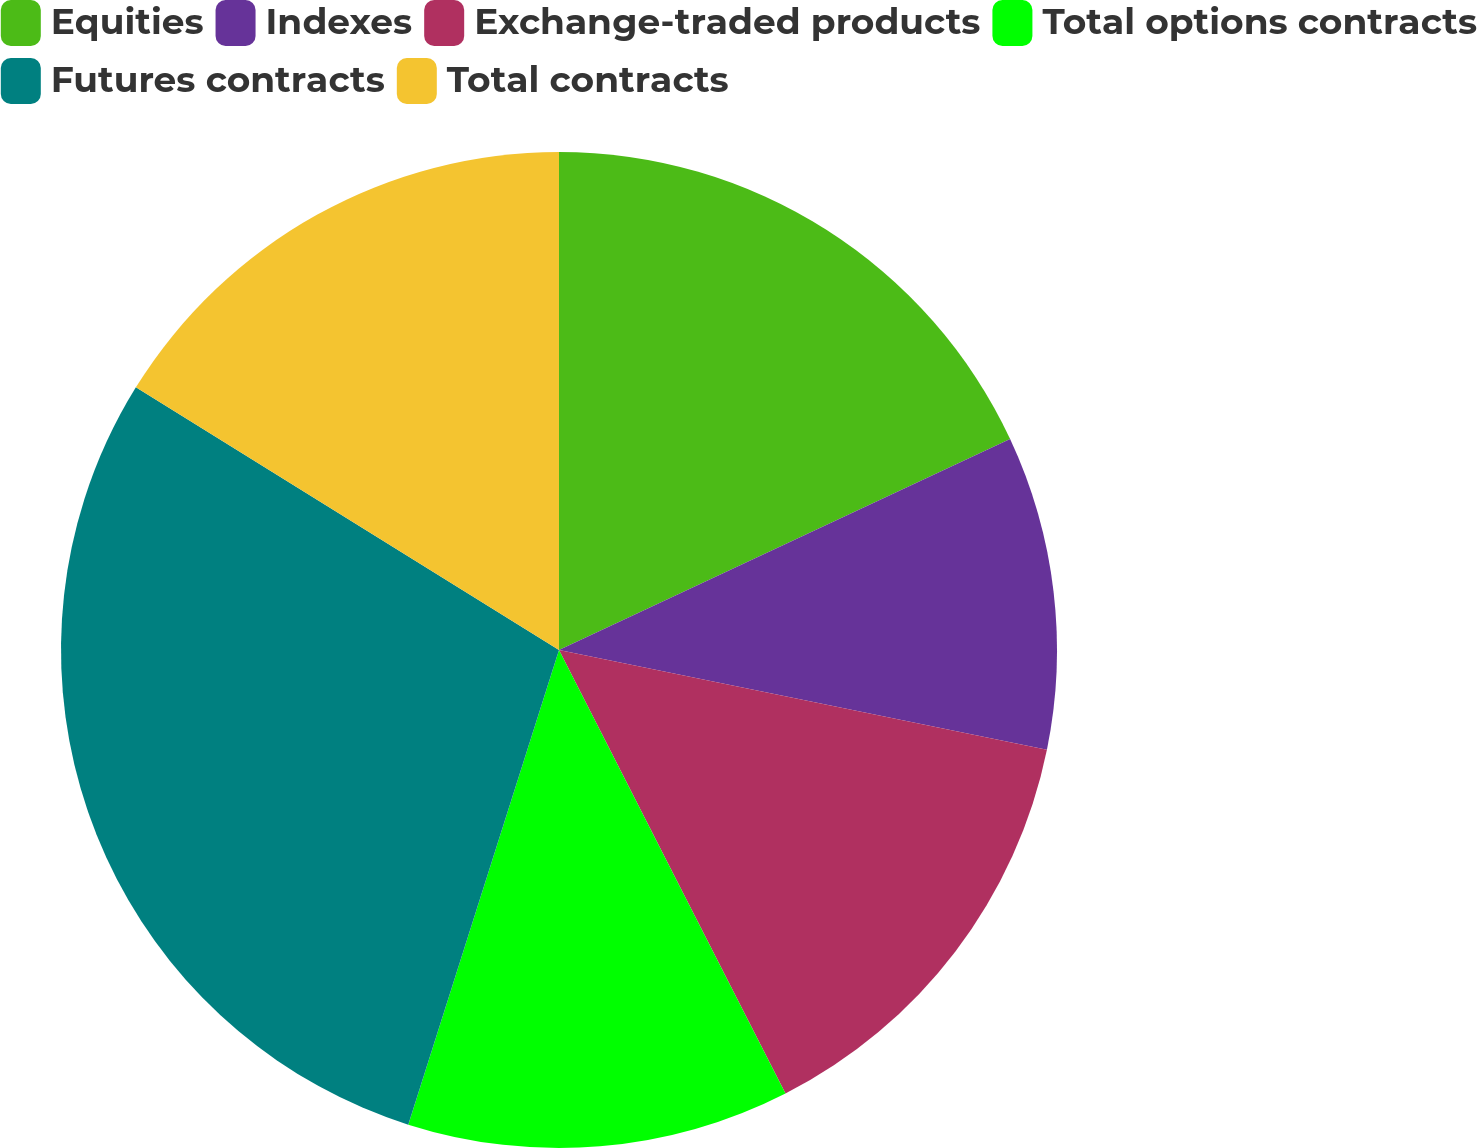Convert chart. <chart><loc_0><loc_0><loc_500><loc_500><pie_chart><fcel>Equities<fcel>Indexes<fcel>Exchange-traded products<fcel>Total options contracts<fcel>Futures contracts<fcel>Total contracts<nl><fcel>18.04%<fcel>10.17%<fcel>14.28%<fcel>12.41%<fcel>28.95%<fcel>16.16%<nl></chart> 